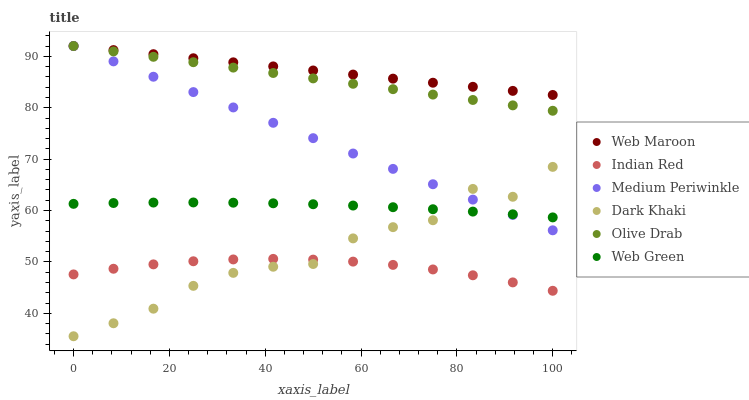Does Indian Red have the minimum area under the curve?
Answer yes or no. Yes. Does Web Maroon have the maximum area under the curve?
Answer yes or no. Yes. Does Medium Periwinkle have the minimum area under the curve?
Answer yes or no. No. Does Medium Periwinkle have the maximum area under the curve?
Answer yes or no. No. Is Web Maroon the smoothest?
Answer yes or no. Yes. Is Dark Khaki the roughest?
Answer yes or no. Yes. Is Medium Periwinkle the smoothest?
Answer yes or no. No. Is Medium Periwinkle the roughest?
Answer yes or no. No. Does Dark Khaki have the lowest value?
Answer yes or no. Yes. Does Medium Periwinkle have the lowest value?
Answer yes or no. No. Does Olive Drab have the highest value?
Answer yes or no. Yes. Does Web Green have the highest value?
Answer yes or no. No. Is Dark Khaki less than Olive Drab?
Answer yes or no. Yes. Is Web Maroon greater than Dark Khaki?
Answer yes or no. Yes. Does Web Green intersect Medium Periwinkle?
Answer yes or no. Yes. Is Web Green less than Medium Periwinkle?
Answer yes or no. No. Is Web Green greater than Medium Periwinkle?
Answer yes or no. No. Does Dark Khaki intersect Olive Drab?
Answer yes or no. No. 